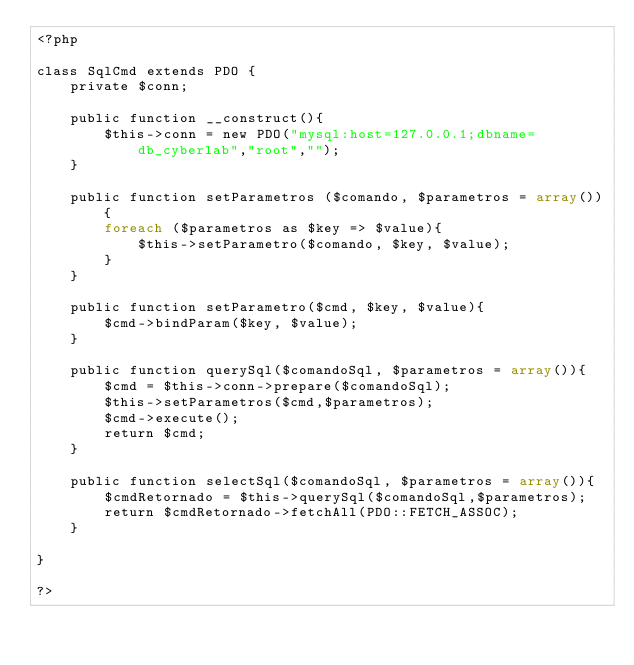Convert code to text. <code><loc_0><loc_0><loc_500><loc_500><_PHP_><?php

class SqlCmd extends PDO {
    private $conn;

    public function __construct(){
        $this->conn = new PDO("mysql:host=127.0.0.1;dbname=db_cyberlab","root","");
    }

    public function setParametros ($comando, $parametros = array()){
        foreach ($parametros as $key => $value){
            $this->setParametro($comando, $key, $value);
        }
    }

    public function setParametro($cmd, $key, $value){
        $cmd->bindParam($key, $value);
    }

    public function querySql($comandoSql, $parametros = array()){
        $cmd = $this->conn->prepare($comandoSql);
        $this->setParametros($cmd,$parametros);
        $cmd->execute();
        return $cmd;
    }

    public function selectSql($comandoSql, $parametros = array()){
        $cmdRetornado = $this->querySql($comandoSql,$parametros);
        return $cmdRetornado->fetchAll(PDO::FETCH_ASSOC);
    }

}

?></code> 